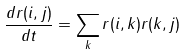<formula> <loc_0><loc_0><loc_500><loc_500>\frac { d r ( i , j ) } { d t } = \sum _ { k } r ( i , k ) r ( k , j )</formula> 